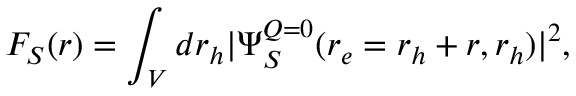Convert formula to latex. <formula><loc_0><loc_0><loc_500><loc_500>F _ { S } ( r ) = \int _ { V } d r _ { h } | \Psi _ { S } ^ { Q = 0 } ( r _ { e } = r _ { h } + r , r _ { h } ) | ^ { 2 } ,</formula> 